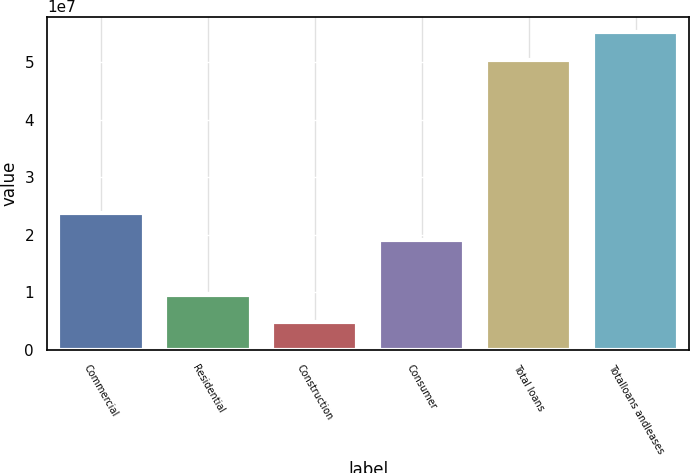Convert chart. <chart><loc_0><loc_0><loc_500><loc_500><bar_chart><fcel>Commercial<fcel>Residential<fcel>Construction<fcel>Consumer<fcel>Total loans<fcel>Totalloans andleases<nl><fcel>2.37585e+07<fcel>9.48456e+06<fcel>4.72657e+06<fcel>1.90005e+07<fcel>5.04292e+07<fcel>5.51871e+07<nl></chart> 